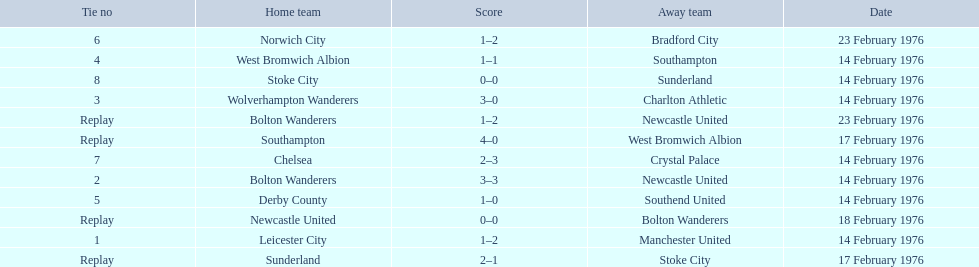What were the home teams in the 1975-76 fa cup? Leicester City, Bolton Wanderers, Newcastle United, Bolton Wanderers, Wolverhampton Wanderers, West Bromwich Albion, Southampton, Derby County, Norwich City, Chelsea, Stoke City, Sunderland. Which of these teams had the tie number 1? Leicester City. 